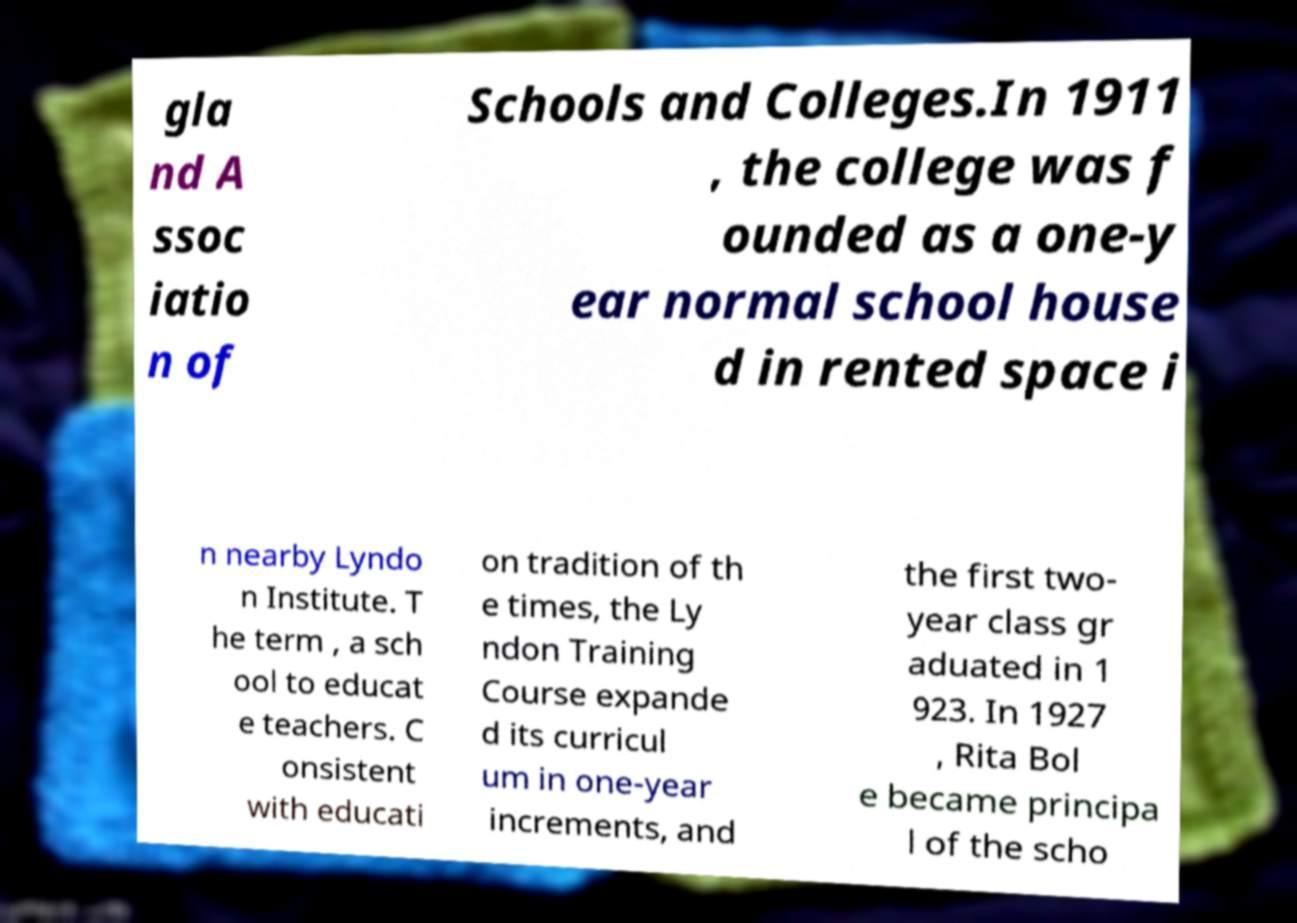Can you accurately transcribe the text from the provided image for me? gla nd A ssoc iatio n of Schools and Colleges.In 1911 , the college was f ounded as a one-y ear normal school house d in rented space i n nearby Lyndo n Institute. T he term , a sch ool to educat e teachers. C onsistent with educati on tradition of th e times, the Ly ndon Training Course expande d its curricul um in one-year increments, and the first two- year class gr aduated in 1 923. In 1927 , Rita Bol e became principa l of the scho 